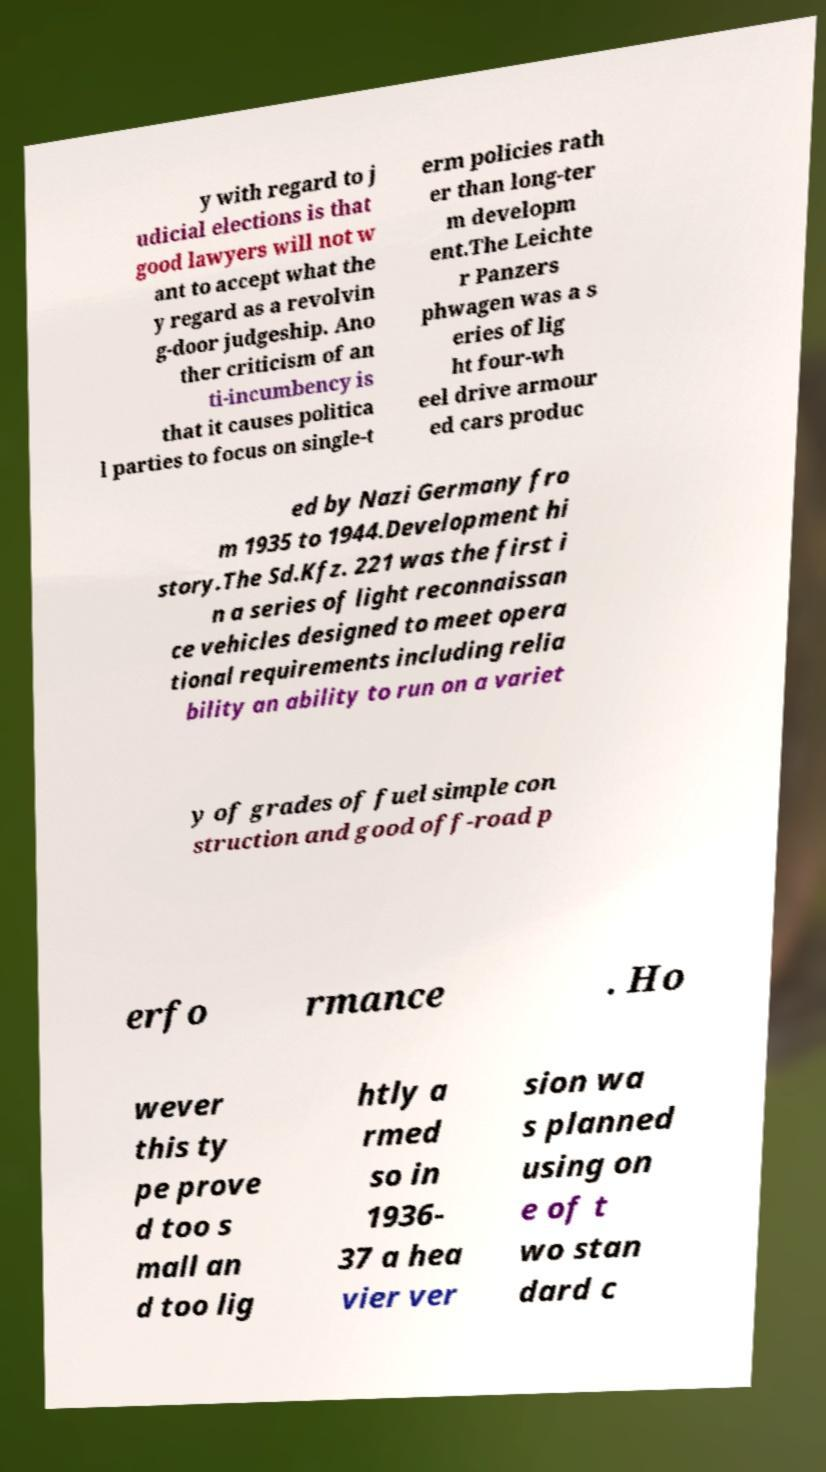For documentation purposes, I need the text within this image transcribed. Could you provide that? y with regard to j udicial elections is that good lawyers will not w ant to accept what the y regard as a revolvin g-door judgeship. Ano ther criticism of an ti-incumbency is that it causes politica l parties to focus on single-t erm policies rath er than long-ter m developm ent.The Leichte r Panzers phwagen was a s eries of lig ht four-wh eel drive armour ed cars produc ed by Nazi Germany fro m 1935 to 1944.Development hi story.The Sd.Kfz. 221 was the first i n a series of light reconnaissan ce vehicles designed to meet opera tional requirements including relia bility an ability to run on a variet y of grades of fuel simple con struction and good off-road p erfo rmance . Ho wever this ty pe prove d too s mall an d too lig htly a rmed so in 1936- 37 a hea vier ver sion wa s planned using on e of t wo stan dard c 